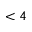Convert formula to latex. <formula><loc_0><loc_0><loc_500><loc_500>< 4</formula> 